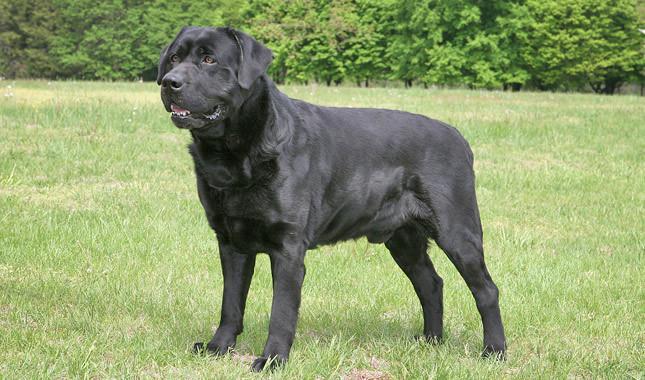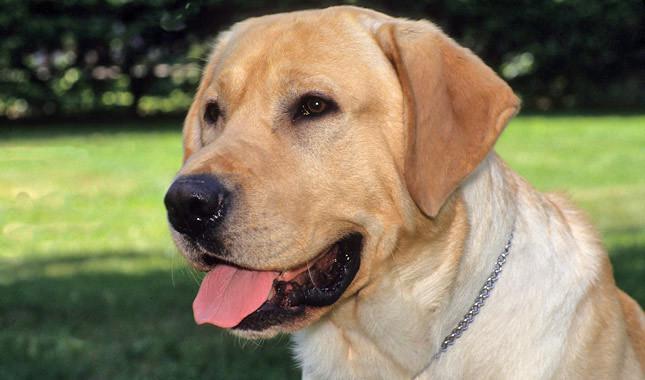The first image is the image on the left, the second image is the image on the right. For the images shown, is this caption "Only one of the dogs is black." true? Answer yes or no. Yes. 